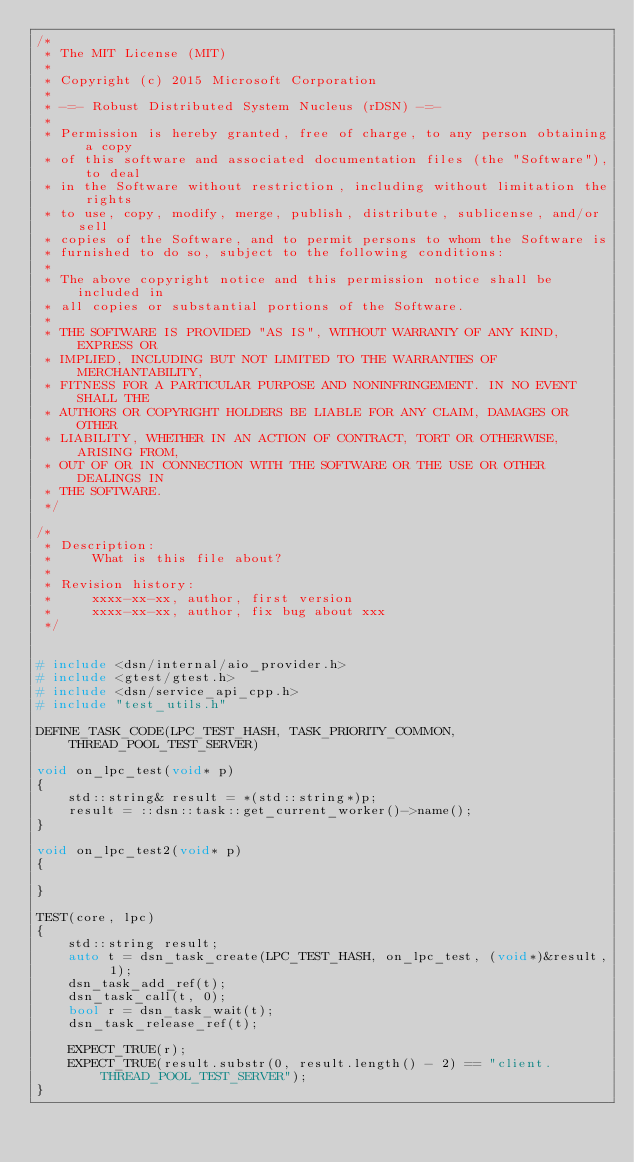<code> <loc_0><loc_0><loc_500><loc_500><_C++_>/*
 * The MIT License (MIT)
 *
 * Copyright (c) 2015 Microsoft Corporation
 * 
 * -=- Robust Distributed System Nucleus (rDSN) -=- 
 *
 * Permission is hereby granted, free of charge, to any person obtaining a copy
 * of this software and associated documentation files (the "Software"), to deal
 * in the Software without restriction, including without limitation the rights
 * to use, copy, modify, merge, publish, distribute, sublicense, and/or sell
 * copies of the Software, and to permit persons to whom the Software is
 * furnished to do so, subject to the following conditions:
 *
 * The above copyright notice and this permission notice shall be included in
 * all copies or substantial portions of the Software.
 *
 * THE SOFTWARE IS PROVIDED "AS IS", WITHOUT WARRANTY OF ANY KIND, EXPRESS OR
 * IMPLIED, INCLUDING BUT NOT LIMITED TO THE WARRANTIES OF MERCHANTABILITY,
 * FITNESS FOR A PARTICULAR PURPOSE AND NONINFRINGEMENT. IN NO EVENT SHALL THE
 * AUTHORS OR COPYRIGHT HOLDERS BE LIABLE FOR ANY CLAIM, DAMAGES OR OTHER
 * LIABILITY, WHETHER IN AN ACTION OF CONTRACT, TORT OR OTHERWISE, ARISING FROM,
 * OUT OF OR IN CONNECTION WITH THE SOFTWARE OR THE USE OR OTHER DEALINGS IN
 * THE SOFTWARE.
 */

/*
 * Description:
 *     What is this file about?
 *
 * Revision history:
 *     xxxx-xx-xx, author, first version
 *     xxxx-xx-xx, author, fix bug about xxx
 */


# include <dsn/internal/aio_provider.h>
# include <gtest/gtest.h>
# include <dsn/service_api_cpp.h>
# include "test_utils.h"

DEFINE_TASK_CODE(LPC_TEST_HASH, TASK_PRIORITY_COMMON, THREAD_POOL_TEST_SERVER)

void on_lpc_test(void* p)
{
    std::string& result = *(std::string*)p;
    result = ::dsn::task::get_current_worker()->name();
}

void on_lpc_test2(void* p)
{

}

TEST(core, lpc)
{
    std::string result;
    auto t = dsn_task_create(LPC_TEST_HASH, on_lpc_test, (void*)&result, 1);
    dsn_task_add_ref(t);
    dsn_task_call(t, 0);
    bool r = dsn_task_wait(t);
    dsn_task_release_ref(t);

    EXPECT_TRUE(r);
    EXPECT_TRUE(result.substr(0, result.length() - 2) == "client.THREAD_POOL_TEST_SERVER");
}
</code> 